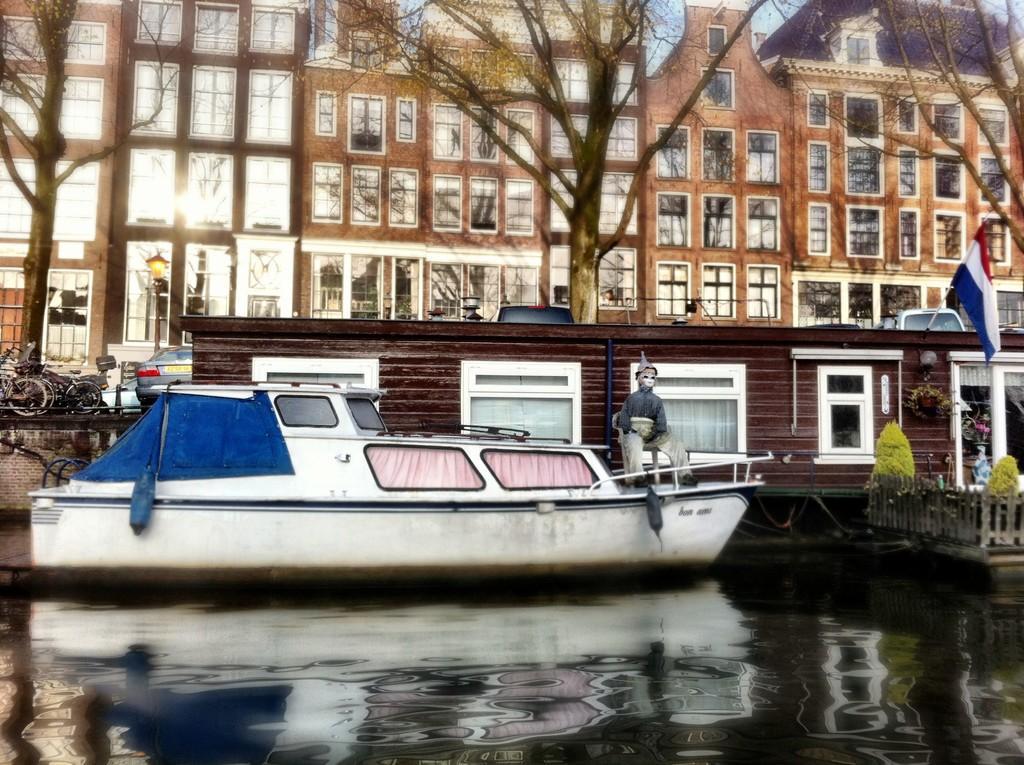In one or two sentences, can you explain what this image depicts? In this image we can see a boat on the water and there is a toy which resembles like a person and to the side we can see a house and there is a flag. We can see some trees and plants and there are some vehicles and in the background, we can see some buildings. 